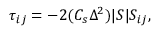Convert formula to latex. <formula><loc_0><loc_0><loc_500><loc_500>\tau _ { i j } = - 2 ( C _ { s } \Delta ^ { 2 } ) | S | S _ { i j } ,</formula> 